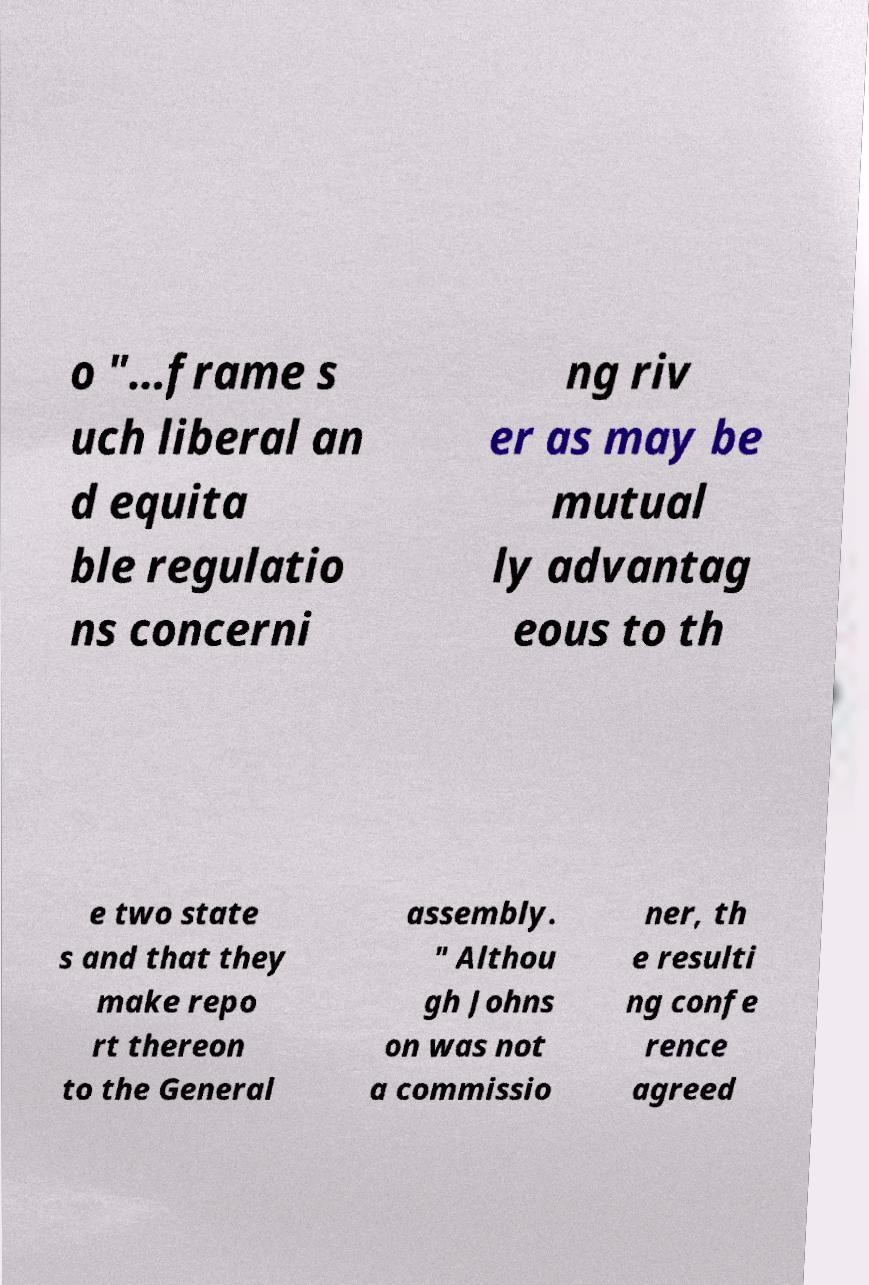Can you read and provide the text displayed in the image?This photo seems to have some interesting text. Can you extract and type it out for me? o "…frame s uch liberal an d equita ble regulatio ns concerni ng riv er as may be mutual ly advantag eous to th e two state s and that they make repo rt thereon to the General assembly. " Althou gh Johns on was not a commissio ner, th e resulti ng confe rence agreed 